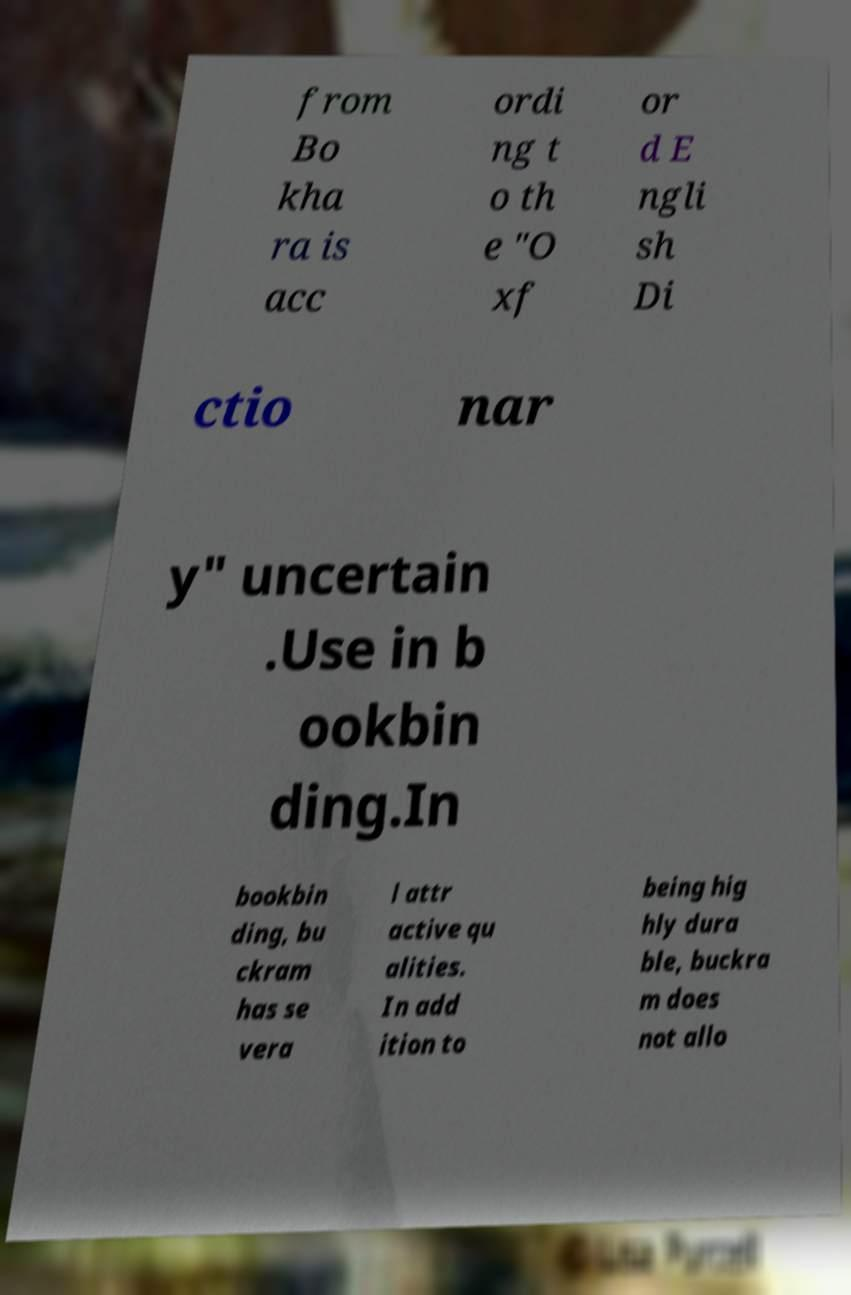There's text embedded in this image that I need extracted. Can you transcribe it verbatim? from Bo kha ra is acc ordi ng t o th e "O xf or d E ngli sh Di ctio nar y" uncertain .Use in b ookbin ding.In bookbin ding, bu ckram has se vera l attr active qu alities. In add ition to being hig hly dura ble, buckra m does not allo 